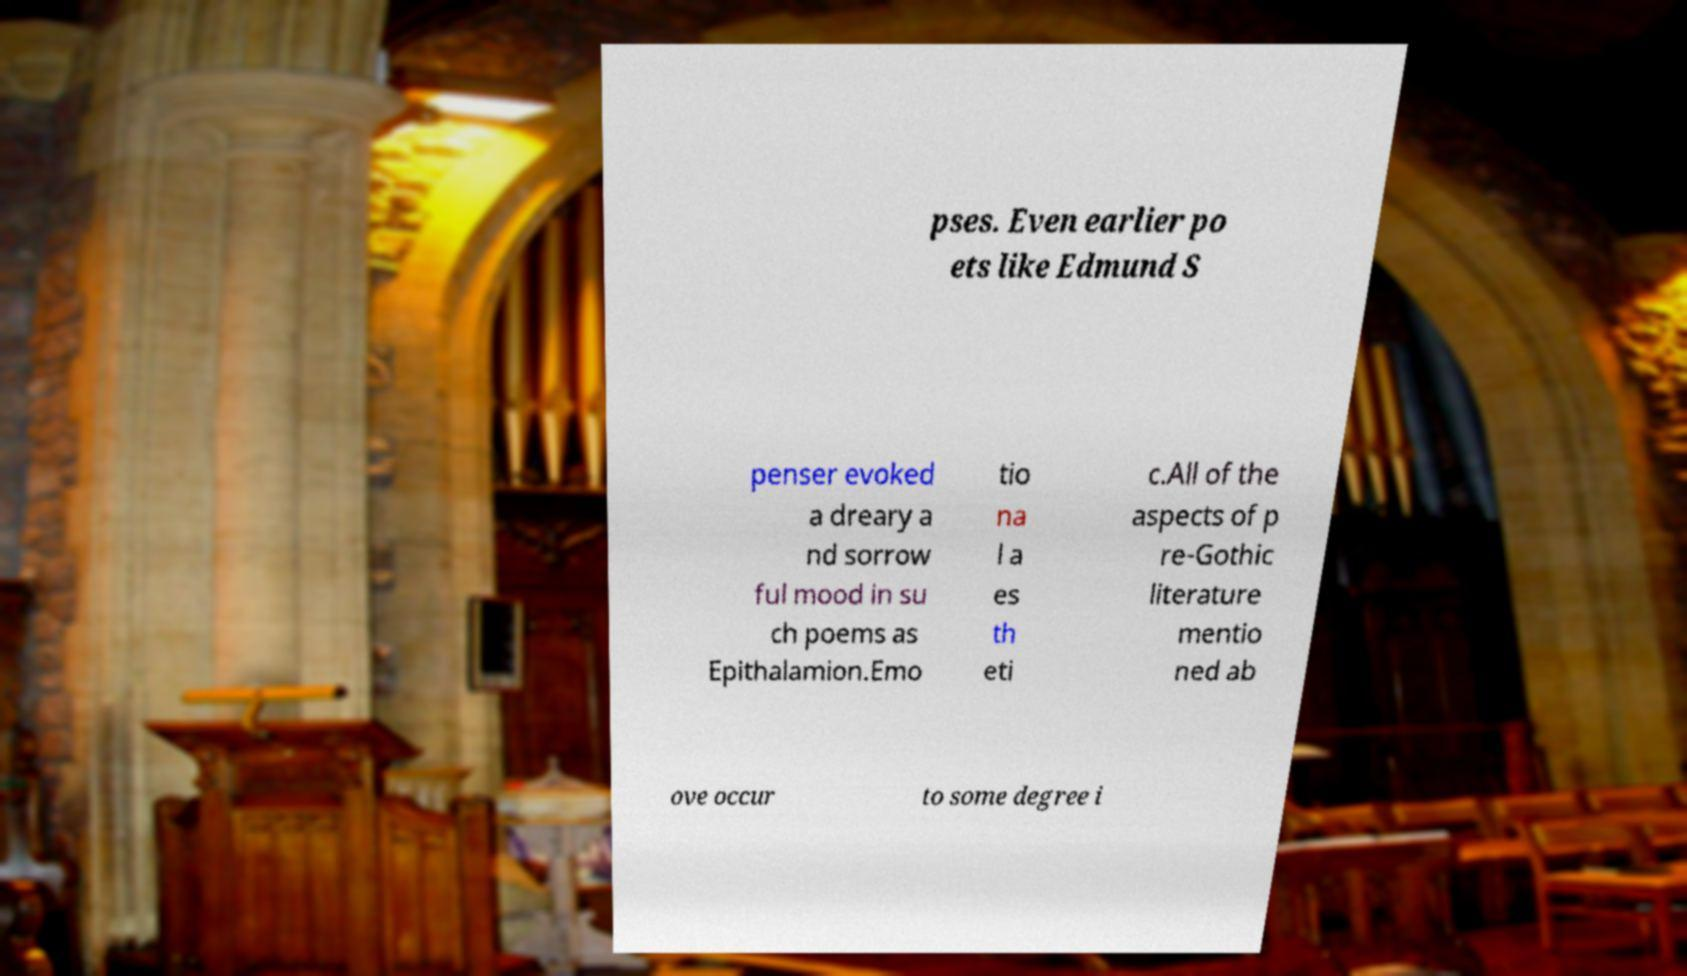Can you read and provide the text displayed in the image?This photo seems to have some interesting text. Can you extract and type it out for me? pses. Even earlier po ets like Edmund S penser evoked a dreary a nd sorrow ful mood in su ch poems as Epithalamion.Emo tio na l a es th eti c.All of the aspects of p re-Gothic literature mentio ned ab ove occur to some degree i 